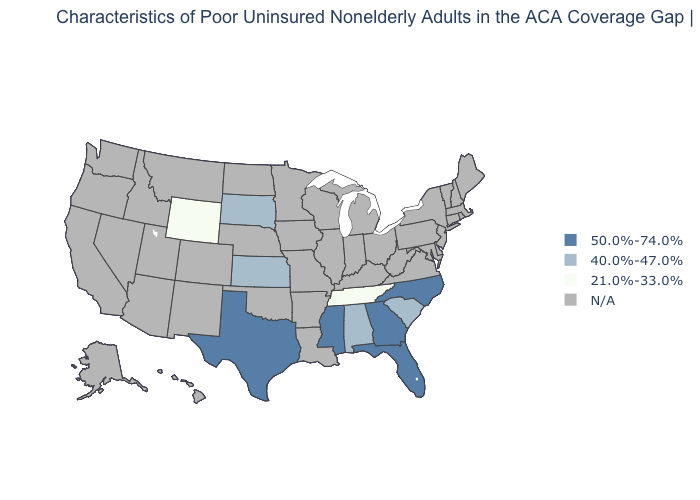Among the states that border Iowa , which have the highest value?
Give a very brief answer. South Dakota. Is the legend a continuous bar?
Answer briefly. No. What is the value of Mississippi?
Give a very brief answer. 50.0%-74.0%. Which states have the lowest value in the South?
Answer briefly. Tennessee. Name the states that have a value in the range 40.0%-47.0%?
Answer briefly. Alabama, Kansas, South Carolina, South Dakota. What is the highest value in the West ?
Answer briefly. 21.0%-33.0%. Name the states that have a value in the range 21.0%-33.0%?
Quick response, please. Tennessee, Wyoming. Is the legend a continuous bar?
Write a very short answer. No. What is the highest value in states that border Tennessee?
Short answer required. 50.0%-74.0%. Among the states that border Utah , which have the lowest value?
Be succinct. Wyoming. 